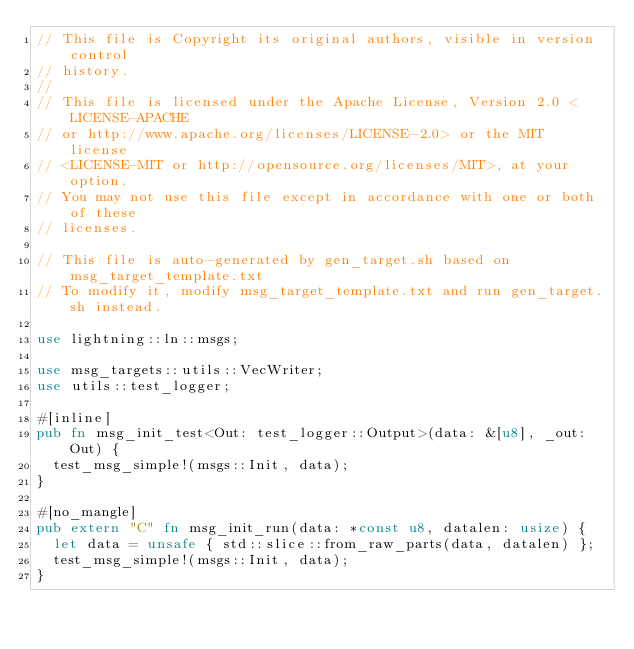Convert code to text. <code><loc_0><loc_0><loc_500><loc_500><_Rust_>// This file is Copyright its original authors, visible in version control
// history.
//
// This file is licensed under the Apache License, Version 2.0 <LICENSE-APACHE
// or http://www.apache.org/licenses/LICENSE-2.0> or the MIT license
// <LICENSE-MIT or http://opensource.org/licenses/MIT>, at your option.
// You may not use this file except in accordance with one or both of these
// licenses.

// This file is auto-generated by gen_target.sh based on msg_target_template.txt
// To modify it, modify msg_target_template.txt and run gen_target.sh instead.

use lightning::ln::msgs;

use msg_targets::utils::VecWriter;
use utils::test_logger;

#[inline]
pub fn msg_init_test<Out: test_logger::Output>(data: &[u8], _out: Out) {
	test_msg_simple!(msgs::Init, data);
}

#[no_mangle]
pub extern "C" fn msg_init_run(data: *const u8, datalen: usize) {
	let data = unsafe { std::slice::from_raw_parts(data, datalen) };
	test_msg_simple!(msgs::Init, data);
}
</code> 